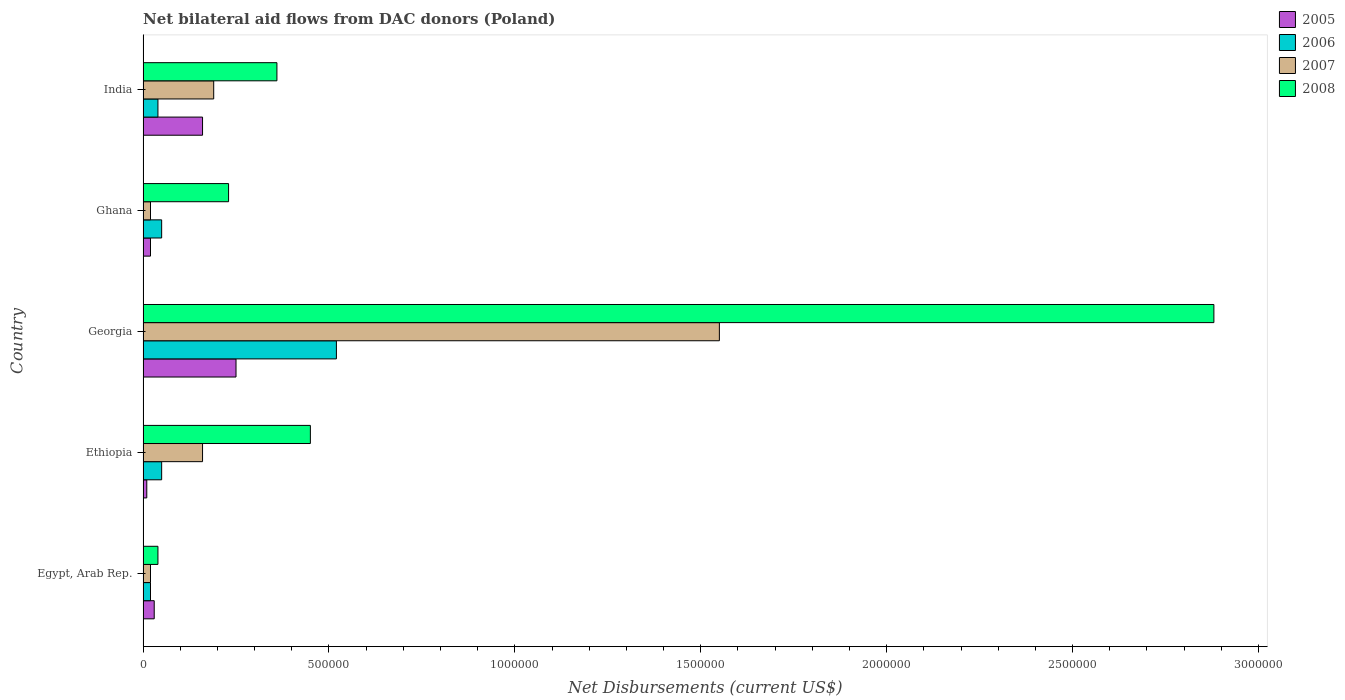How many bars are there on the 1st tick from the top?
Offer a terse response. 4. How many bars are there on the 3rd tick from the bottom?
Your response must be concise. 4. What is the label of the 4th group of bars from the top?
Make the answer very short. Ethiopia. Across all countries, what is the maximum net bilateral aid flows in 2006?
Make the answer very short. 5.20e+05. In which country was the net bilateral aid flows in 2007 maximum?
Provide a succinct answer. Georgia. In which country was the net bilateral aid flows in 2008 minimum?
Keep it short and to the point. Egypt, Arab Rep. What is the total net bilateral aid flows in 2007 in the graph?
Your response must be concise. 1.94e+06. What is the average net bilateral aid flows in 2006 per country?
Provide a short and direct response. 1.36e+05. In how many countries, is the net bilateral aid flows in 2007 greater than 2500000 US$?
Offer a very short reply. 0. What is the difference between the highest and the second highest net bilateral aid flows in 2005?
Your answer should be compact. 9.00e+04. In how many countries, is the net bilateral aid flows in 2008 greater than the average net bilateral aid flows in 2008 taken over all countries?
Your response must be concise. 1. What does the 2nd bar from the top in India represents?
Provide a succinct answer. 2007. What does the 4th bar from the bottom in Georgia represents?
Make the answer very short. 2008. How many bars are there?
Provide a short and direct response. 20. Are the values on the major ticks of X-axis written in scientific E-notation?
Keep it short and to the point. No. Does the graph contain grids?
Keep it short and to the point. No. How many legend labels are there?
Your answer should be compact. 4. How are the legend labels stacked?
Provide a succinct answer. Vertical. What is the title of the graph?
Provide a short and direct response. Net bilateral aid flows from DAC donors (Poland). Does "1976" appear as one of the legend labels in the graph?
Offer a terse response. No. What is the label or title of the X-axis?
Your answer should be compact. Net Disbursements (current US$). What is the label or title of the Y-axis?
Provide a succinct answer. Country. What is the Net Disbursements (current US$) of 2005 in Ethiopia?
Offer a terse response. 10000. What is the Net Disbursements (current US$) of 2006 in Ethiopia?
Keep it short and to the point. 5.00e+04. What is the Net Disbursements (current US$) of 2007 in Ethiopia?
Keep it short and to the point. 1.60e+05. What is the Net Disbursements (current US$) of 2008 in Ethiopia?
Give a very brief answer. 4.50e+05. What is the Net Disbursements (current US$) in 2006 in Georgia?
Give a very brief answer. 5.20e+05. What is the Net Disbursements (current US$) of 2007 in Georgia?
Your answer should be compact. 1.55e+06. What is the Net Disbursements (current US$) in 2008 in Georgia?
Ensure brevity in your answer.  2.88e+06. What is the Net Disbursements (current US$) in 2005 in Ghana?
Your response must be concise. 2.00e+04. What is the Net Disbursements (current US$) in 2006 in Ghana?
Provide a short and direct response. 5.00e+04. What is the Net Disbursements (current US$) in 2007 in Ghana?
Make the answer very short. 2.00e+04. What is the Net Disbursements (current US$) of 2008 in Ghana?
Provide a short and direct response. 2.30e+05. What is the Net Disbursements (current US$) of 2005 in India?
Your answer should be compact. 1.60e+05. What is the Net Disbursements (current US$) in 2006 in India?
Your response must be concise. 4.00e+04. What is the Net Disbursements (current US$) of 2007 in India?
Make the answer very short. 1.90e+05. Across all countries, what is the maximum Net Disbursements (current US$) of 2005?
Provide a short and direct response. 2.50e+05. Across all countries, what is the maximum Net Disbursements (current US$) of 2006?
Keep it short and to the point. 5.20e+05. Across all countries, what is the maximum Net Disbursements (current US$) in 2007?
Provide a short and direct response. 1.55e+06. Across all countries, what is the maximum Net Disbursements (current US$) in 2008?
Your response must be concise. 2.88e+06. Across all countries, what is the minimum Net Disbursements (current US$) in 2005?
Your answer should be very brief. 10000. Across all countries, what is the minimum Net Disbursements (current US$) of 2006?
Make the answer very short. 2.00e+04. Across all countries, what is the minimum Net Disbursements (current US$) of 2008?
Make the answer very short. 4.00e+04. What is the total Net Disbursements (current US$) in 2005 in the graph?
Make the answer very short. 4.70e+05. What is the total Net Disbursements (current US$) of 2006 in the graph?
Give a very brief answer. 6.80e+05. What is the total Net Disbursements (current US$) of 2007 in the graph?
Offer a very short reply. 1.94e+06. What is the total Net Disbursements (current US$) of 2008 in the graph?
Your response must be concise. 3.96e+06. What is the difference between the Net Disbursements (current US$) of 2005 in Egypt, Arab Rep. and that in Ethiopia?
Offer a terse response. 2.00e+04. What is the difference between the Net Disbursements (current US$) of 2008 in Egypt, Arab Rep. and that in Ethiopia?
Your answer should be very brief. -4.10e+05. What is the difference between the Net Disbursements (current US$) in 2005 in Egypt, Arab Rep. and that in Georgia?
Your response must be concise. -2.20e+05. What is the difference between the Net Disbursements (current US$) in 2006 in Egypt, Arab Rep. and that in Georgia?
Keep it short and to the point. -5.00e+05. What is the difference between the Net Disbursements (current US$) in 2007 in Egypt, Arab Rep. and that in Georgia?
Your answer should be very brief. -1.53e+06. What is the difference between the Net Disbursements (current US$) of 2008 in Egypt, Arab Rep. and that in Georgia?
Give a very brief answer. -2.84e+06. What is the difference between the Net Disbursements (current US$) in 2006 in Egypt, Arab Rep. and that in Ghana?
Make the answer very short. -3.00e+04. What is the difference between the Net Disbursements (current US$) in 2007 in Egypt, Arab Rep. and that in Ghana?
Provide a short and direct response. 0. What is the difference between the Net Disbursements (current US$) in 2008 in Egypt, Arab Rep. and that in Ghana?
Offer a very short reply. -1.90e+05. What is the difference between the Net Disbursements (current US$) of 2006 in Egypt, Arab Rep. and that in India?
Your answer should be compact. -2.00e+04. What is the difference between the Net Disbursements (current US$) in 2007 in Egypt, Arab Rep. and that in India?
Ensure brevity in your answer.  -1.70e+05. What is the difference between the Net Disbursements (current US$) in 2008 in Egypt, Arab Rep. and that in India?
Give a very brief answer. -3.20e+05. What is the difference between the Net Disbursements (current US$) in 2005 in Ethiopia and that in Georgia?
Provide a succinct answer. -2.40e+05. What is the difference between the Net Disbursements (current US$) of 2006 in Ethiopia and that in Georgia?
Offer a very short reply. -4.70e+05. What is the difference between the Net Disbursements (current US$) in 2007 in Ethiopia and that in Georgia?
Give a very brief answer. -1.39e+06. What is the difference between the Net Disbursements (current US$) of 2008 in Ethiopia and that in Georgia?
Your answer should be very brief. -2.43e+06. What is the difference between the Net Disbursements (current US$) of 2007 in Ethiopia and that in Ghana?
Give a very brief answer. 1.40e+05. What is the difference between the Net Disbursements (current US$) of 2005 in Ethiopia and that in India?
Give a very brief answer. -1.50e+05. What is the difference between the Net Disbursements (current US$) of 2006 in Ethiopia and that in India?
Provide a succinct answer. 10000. What is the difference between the Net Disbursements (current US$) in 2007 in Ethiopia and that in India?
Keep it short and to the point. -3.00e+04. What is the difference between the Net Disbursements (current US$) of 2005 in Georgia and that in Ghana?
Your response must be concise. 2.30e+05. What is the difference between the Net Disbursements (current US$) of 2006 in Georgia and that in Ghana?
Your response must be concise. 4.70e+05. What is the difference between the Net Disbursements (current US$) in 2007 in Georgia and that in Ghana?
Offer a very short reply. 1.53e+06. What is the difference between the Net Disbursements (current US$) in 2008 in Georgia and that in Ghana?
Your response must be concise. 2.65e+06. What is the difference between the Net Disbursements (current US$) of 2006 in Georgia and that in India?
Your answer should be very brief. 4.80e+05. What is the difference between the Net Disbursements (current US$) of 2007 in Georgia and that in India?
Provide a succinct answer. 1.36e+06. What is the difference between the Net Disbursements (current US$) of 2008 in Georgia and that in India?
Your answer should be very brief. 2.52e+06. What is the difference between the Net Disbursements (current US$) of 2005 in Ghana and that in India?
Provide a succinct answer. -1.40e+05. What is the difference between the Net Disbursements (current US$) in 2007 in Ghana and that in India?
Give a very brief answer. -1.70e+05. What is the difference between the Net Disbursements (current US$) of 2008 in Ghana and that in India?
Provide a short and direct response. -1.30e+05. What is the difference between the Net Disbursements (current US$) in 2005 in Egypt, Arab Rep. and the Net Disbursements (current US$) in 2006 in Ethiopia?
Your answer should be compact. -2.00e+04. What is the difference between the Net Disbursements (current US$) of 2005 in Egypt, Arab Rep. and the Net Disbursements (current US$) of 2008 in Ethiopia?
Offer a very short reply. -4.20e+05. What is the difference between the Net Disbursements (current US$) in 2006 in Egypt, Arab Rep. and the Net Disbursements (current US$) in 2007 in Ethiopia?
Ensure brevity in your answer.  -1.40e+05. What is the difference between the Net Disbursements (current US$) of 2006 in Egypt, Arab Rep. and the Net Disbursements (current US$) of 2008 in Ethiopia?
Provide a short and direct response. -4.30e+05. What is the difference between the Net Disbursements (current US$) of 2007 in Egypt, Arab Rep. and the Net Disbursements (current US$) of 2008 in Ethiopia?
Offer a very short reply. -4.30e+05. What is the difference between the Net Disbursements (current US$) in 2005 in Egypt, Arab Rep. and the Net Disbursements (current US$) in 2006 in Georgia?
Ensure brevity in your answer.  -4.90e+05. What is the difference between the Net Disbursements (current US$) of 2005 in Egypt, Arab Rep. and the Net Disbursements (current US$) of 2007 in Georgia?
Make the answer very short. -1.52e+06. What is the difference between the Net Disbursements (current US$) in 2005 in Egypt, Arab Rep. and the Net Disbursements (current US$) in 2008 in Georgia?
Give a very brief answer. -2.85e+06. What is the difference between the Net Disbursements (current US$) of 2006 in Egypt, Arab Rep. and the Net Disbursements (current US$) of 2007 in Georgia?
Provide a succinct answer. -1.53e+06. What is the difference between the Net Disbursements (current US$) of 2006 in Egypt, Arab Rep. and the Net Disbursements (current US$) of 2008 in Georgia?
Make the answer very short. -2.86e+06. What is the difference between the Net Disbursements (current US$) of 2007 in Egypt, Arab Rep. and the Net Disbursements (current US$) of 2008 in Georgia?
Make the answer very short. -2.86e+06. What is the difference between the Net Disbursements (current US$) of 2005 in Egypt, Arab Rep. and the Net Disbursements (current US$) of 2007 in Ghana?
Make the answer very short. 10000. What is the difference between the Net Disbursements (current US$) of 2005 in Egypt, Arab Rep. and the Net Disbursements (current US$) of 2008 in Ghana?
Offer a very short reply. -2.00e+05. What is the difference between the Net Disbursements (current US$) in 2005 in Egypt, Arab Rep. and the Net Disbursements (current US$) in 2007 in India?
Your response must be concise. -1.60e+05. What is the difference between the Net Disbursements (current US$) in 2005 in Egypt, Arab Rep. and the Net Disbursements (current US$) in 2008 in India?
Provide a short and direct response. -3.30e+05. What is the difference between the Net Disbursements (current US$) in 2006 in Egypt, Arab Rep. and the Net Disbursements (current US$) in 2007 in India?
Provide a succinct answer. -1.70e+05. What is the difference between the Net Disbursements (current US$) in 2007 in Egypt, Arab Rep. and the Net Disbursements (current US$) in 2008 in India?
Provide a short and direct response. -3.40e+05. What is the difference between the Net Disbursements (current US$) of 2005 in Ethiopia and the Net Disbursements (current US$) of 2006 in Georgia?
Keep it short and to the point. -5.10e+05. What is the difference between the Net Disbursements (current US$) of 2005 in Ethiopia and the Net Disbursements (current US$) of 2007 in Georgia?
Your response must be concise. -1.54e+06. What is the difference between the Net Disbursements (current US$) of 2005 in Ethiopia and the Net Disbursements (current US$) of 2008 in Georgia?
Ensure brevity in your answer.  -2.87e+06. What is the difference between the Net Disbursements (current US$) in 2006 in Ethiopia and the Net Disbursements (current US$) in 2007 in Georgia?
Provide a short and direct response. -1.50e+06. What is the difference between the Net Disbursements (current US$) in 2006 in Ethiopia and the Net Disbursements (current US$) in 2008 in Georgia?
Offer a very short reply. -2.83e+06. What is the difference between the Net Disbursements (current US$) in 2007 in Ethiopia and the Net Disbursements (current US$) in 2008 in Georgia?
Provide a succinct answer. -2.72e+06. What is the difference between the Net Disbursements (current US$) of 2005 in Ethiopia and the Net Disbursements (current US$) of 2007 in Ghana?
Provide a short and direct response. -10000. What is the difference between the Net Disbursements (current US$) of 2005 in Ethiopia and the Net Disbursements (current US$) of 2008 in Ghana?
Your response must be concise. -2.20e+05. What is the difference between the Net Disbursements (current US$) of 2006 in Ethiopia and the Net Disbursements (current US$) of 2008 in Ghana?
Your answer should be compact. -1.80e+05. What is the difference between the Net Disbursements (current US$) in 2007 in Ethiopia and the Net Disbursements (current US$) in 2008 in Ghana?
Make the answer very short. -7.00e+04. What is the difference between the Net Disbursements (current US$) in 2005 in Ethiopia and the Net Disbursements (current US$) in 2006 in India?
Make the answer very short. -3.00e+04. What is the difference between the Net Disbursements (current US$) of 2005 in Ethiopia and the Net Disbursements (current US$) of 2007 in India?
Provide a succinct answer. -1.80e+05. What is the difference between the Net Disbursements (current US$) of 2005 in Ethiopia and the Net Disbursements (current US$) of 2008 in India?
Your answer should be very brief. -3.50e+05. What is the difference between the Net Disbursements (current US$) of 2006 in Ethiopia and the Net Disbursements (current US$) of 2007 in India?
Give a very brief answer. -1.40e+05. What is the difference between the Net Disbursements (current US$) in 2006 in Ethiopia and the Net Disbursements (current US$) in 2008 in India?
Provide a short and direct response. -3.10e+05. What is the difference between the Net Disbursements (current US$) of 2007 in Ethiopia and the Net Disbursements (current US$) of 2008 in India?
Give a very brief answer. -2.00e+05. What is the difference between the Net Disbursements (current US$) of 2005 in Georgia and the Net Disbursements (current US$) of 2008 in Ghana?
Offer a very short reply. 2.00e+04. What is the difference between the Net Disbursements (current US$) in 2007 in Georgia and the Net Disbursements (current US$) in 2008 in Ghana?
Your response must be concise. 1.32e+06. What is the difference between the Net Disbursements (current US$) of 2005 in Georgia and the Net Disbursements (current US$) of 2006 in India?
Offer a very short reply. 2.10e+05. What is the difference between the Net Disbursements (current US$) of 2007 in Georgia and the Net Disbursements (current US$) of 2008 in India?
Provide a short and direct response. 1.19e+06. What is the difference between the Net Disbursements (current US$) of 2005 in Ghana and the Net Disbursements (current US$) of 2008 in India?
Give a very brief answer. -3.40e+05. What is the difference between the Net Disbursements (current US$) of 2006 in Ghana and the Net Disbursements (current US$) of 2008 in India?
Your answer should be very brief. -3.10e+05. What is the difference between the Net Disbursements (current US$) in 2007 in Ghana and the Net Disbursements (current US$) in 2008 in India?
Your answer should be compact. -3.40e+05. What is the average Net Disbursements (current US$) of 2005 per country?
Your answer should be compact. 9.40e+04. What is the average Net Disbursements (current US$) of 2006 per country?
Your answer should be very brief. 1.36e+05. What is the average Net Disbursements (current US$) of 2007 per country?
Give a very brief answer. 3.88e+05. What is the average Net Disbursements (current US$) in 2008 per country?
Make the answer very short. 7.92e+05. What is the difference between the Net Disbursements (current US$) in 2006 and Net Disbursements (current US$) in 2007 in Egypt, Arab Rep.?
Keep it short and to the point. 0. What is the difference between the Net Disbursements (current US$) of 2007 and Net Disbursements (current US$) of 2008 in Egypt, Arab Rep.?
Make the answer very short. -2.00e+04. What is the difference between the Net Disbursements (current US$) of 2005 and Net Disbursements (current US$) of 2006 in Ethiopia?
Ensure brevity in your answer.  -4.00e+04. What is the difference between the Net Disbursements (current US$) in 2005 and Net Disbursements (current US$) in 2008 in Ethiopia?
Provide a short and direct response. -4.40e+05. What is the difference between the Net Disbursements (current US$) of 2006 and Net Disbursements (current US$) of 2007 in Ethiopia?
Offer a very short reply. -1.10e+05. What is the difference between the Net Disbursements (current US$) in 2006 and Net Disbursements (current US$) in 2008 in Ethiopia?
Your answer should be compact. -4.00e+05. What is the difference between the Net Disbursements (current US$) of 2005 and Net Disbursements (current US$) of 2007 in Georgia?
Your response must be concise. -1.30e+06. What is the difference between the Net Disbursements (current US$) in 2005 and Net Disbursements (current US$) in 2008 in Georgia?
Provide a short and direct response. -2.63e+06. What is the difference between the Net Disbursements (current US$) in 2006 and Net Disbursements (current US$) in 2007 in Georgia?
Offer a very short reply. -1.03e+06. What is the difference between the Net Disbursements (current US$) of 2006 and Net Disbursements (current US$) of 2008 in Georgia?
Give a very brief answer. -2.36e+06. What is the difference between the Net Disbursements (current US$) of 2007 and Net Disbursements (current US$) of 2008 in Georgia?
Your response must be concise. -1.33e+06. What is the difference between the Net Disbursements (current US$) of 2005 and Net Disbursements (current US$) of 2006 in Ghana?
Provide a short and direct response. -3.00e+04. What is the difference between the Net Disbursements (current US$) in 2005 and Net Disbursements (current US$) in 2007 in Ghana?
Keep it short and to the point. 0. What is the difference between the Net Disbursements (current US$) of 2006 and Net Disbursements (current US$) of 2007 in Ghana?
Make the answer very short. 3.00e+04. What is the difference between the Net Disbursements (current US$) of 2005 and Net Disbursements (current US$) of 2007 in India?
Offer a terse response. -3.00e+04. What is the difference between the Net Disbursements (current US$) of 2006 and Net Disbursements (current US$) of 2008 in India?
Make the answer very short. -3.20e+05. What is the ratio of the Net Disbursements (current US$) in 2005 in Egypt, Arab Rep. to that in Ethiopia?
Your answer should be compact. 3. What is the ratio of the Net Disbursements (current US$) of 2006 in Egypt, Arab Rep. to that in Ethiopia?
Provide a short and direct response. 0.4. What is the ratio of the Net Disbursements (current US$) of 2008 in Egypt, Arab Rep. to that in Ethiopia?
Offer a terse response. 0.09. What is the ratio of the Net Disbursements (current US$) of 2005 in Egypt, Arab Rep. to that in Georgia?
Ensure brevity in your answer.  0.12. What is the ratio of the Net Disbursements (current US$) in 2006 in Egypt, Arab Rep. to that in Georgia?
Provide a short and direct response. 0.04. What is the ratio of the Net Disbursements (current US$) in 2007 in Egypt, Arab Rep. to that in Georgia?
Offer a terse response. 0.01. What is the ratio of the Net Disbursements (current US$) in 2008 in Egypt, Arab Rep. to that in Georgia?
Your answer should be very brief. 0.01. What is the ratio of the Net Disbursements (current US$) of 2006 in Egypt, Arab Rep. to that in Ghana?
Offer a terse response. 0.4. What is the ratio of the Net Disbursements (current US$) of 2008 in Egypt, Arab Rep. to that in Ghana?
Make the answer very short. 0.17. What is the ratio of the Net Disbursements (current US$) in 2005 in Egypt, Arab Rep. to that in India?
Your answer should be compact. 0.19. What is the ratio of the Net Disbursements (current US$) of 2007 in Egypt, Arab Rep. to that in India?
Ensure brevity in your answer.  0.11. What is the ratio of the Net Disbursements (current US$) in 2008 in Egypt, Arab Rep. to that in India?
Offer a terse response. 0.11. What is the ratio of the Net Disbursements (current US$) of 2006 in Ethiopia to that in Georgia?
Offer a terse response. 0.1. What is the ratio of the Net Disbursements (current US$) of 2007 in Ethiopia to that in Georgia?
Offer a terse response. 0.1. What is the ratio of the Net Disbursements (current US$) of 2008 in Ethiopia to that in Georgia?
Provide a short and direct response. 0.16. What is the ratio of the Net Disbursements (current US$) in 2005 in Ethiopia to that in Ghana?
Offer a terse response. 0.5. What is the ratio of the Net Disbursements (current US$) of 2008 in Ethiopia to that in Ghana?
Keep it short and to the point. 1.96. What is the ratio of the Net Disbursements (current US$) in 2005 in Ethiopia to that in India?
Provide a short and direct response. 0.06. What is the ratio of the Net Disbursements (current US$) in 2007 in Ethiopia to that in India?
Offer a terse response. 0.84. What is the ratio of the Net Disbursements (current US$) of 2008 in Ethiopia to that in India?
Make the answer very short. 1.25. What is the ratio of the Net Disbursements (current US$) in 2005 in Georgia to that in Ghana?
Your answer should be very brief. 12.5. What is the ratio of the Net Disbursements (current US$) in 2007 in Georgia to that in Ghana?
Your answer should be compact. 77.5. What is the ratio of the Net Disbursements (current US$) in 2008 in Georgia to that in Ghana?
Ensure brevity in your answer.  12.52. What is the ratio of the Net Disbursements (current US$) in 2005 in Georgia to that in India?
Offer a terse response. 1.56. What is the ratio of the Net Disbursements (current US$) in 2007 in Georgia to that in India?
Offer a very short reply. 8.16. What is the ratio of the Net Disbursements (current US$) of 2008 in Georgia to that in India?
Keep it short and to the point. 8. What is the ratio of the Net Disbursements (current US$) of 2005 in Ghana to that in India?
Make the answer very short. 0.12. What is the ratio of the Net Disbursements (current US$) in 2007 in Ghana to that in India?
Give a very brief answer. 0.11. What is the ratio of the Net Disbursements (current US$) of 2008 in Ghana to that in India?
Ensure brevity in your answer.  0.64. What is the difference between the highest and the second highest Net Disbursements (current US$) in 2007?
Offer a terse response. 1.36e+06. What is the difference between the highest and the second highest Net Disbursements (current US$) in 2008?
Your response must be concise. 2.43e+06. What is the difference between the highest and the lowest Net Disbursements (current US$) of 2006?
Provide a short and direct response. 5.00e+05. What is the difference between the highest and the lowest Net Disbursements (current US$) in 2007?
Provide a succinct answer. 1.53e+06. What is the difference between the highest and the lowest Net Disbursements (current US$) of 2008?
Provide a short and direct response. 2.84e+06. 